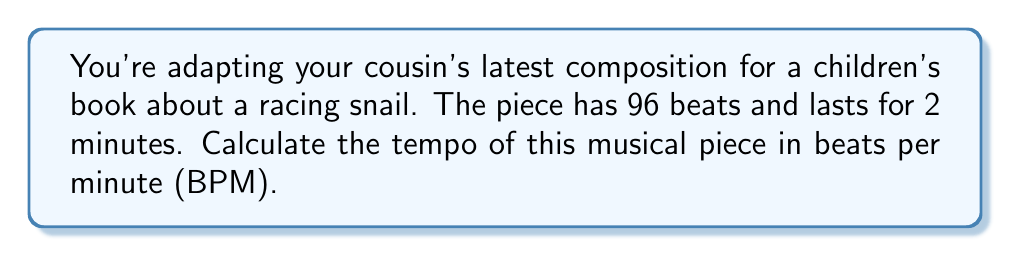Show me your answer to this math problem. Let's approach this step-by-step:

1) First, we need to understand what tempo and beats per minute mean:
   Tempo is the speed of a musical piece, typically measured in beats per minute (BPM).

2) We're given two pieces of information:
   - The piece has 96 beats in total
   - The piece lasts for 2 minutes

3) To find the BPM, we need to calculate how many beats occur in one minute. We can set up the following proportion:

   $$\frac{96 \text{ beats}}{2 \text{ minutes}} = \frac{x \text{ beats}}{1 \text{ minute}}$$

4) Cross multiply:
   $$96 \cdot 1 = 2x$$

5) Solve for x:
   $$x = \frac{96}{2} = 48$$

6) Therefore, there are 48 beats in one minute, which means the tempo is 48 BPM.
Answer: 48 BPM 